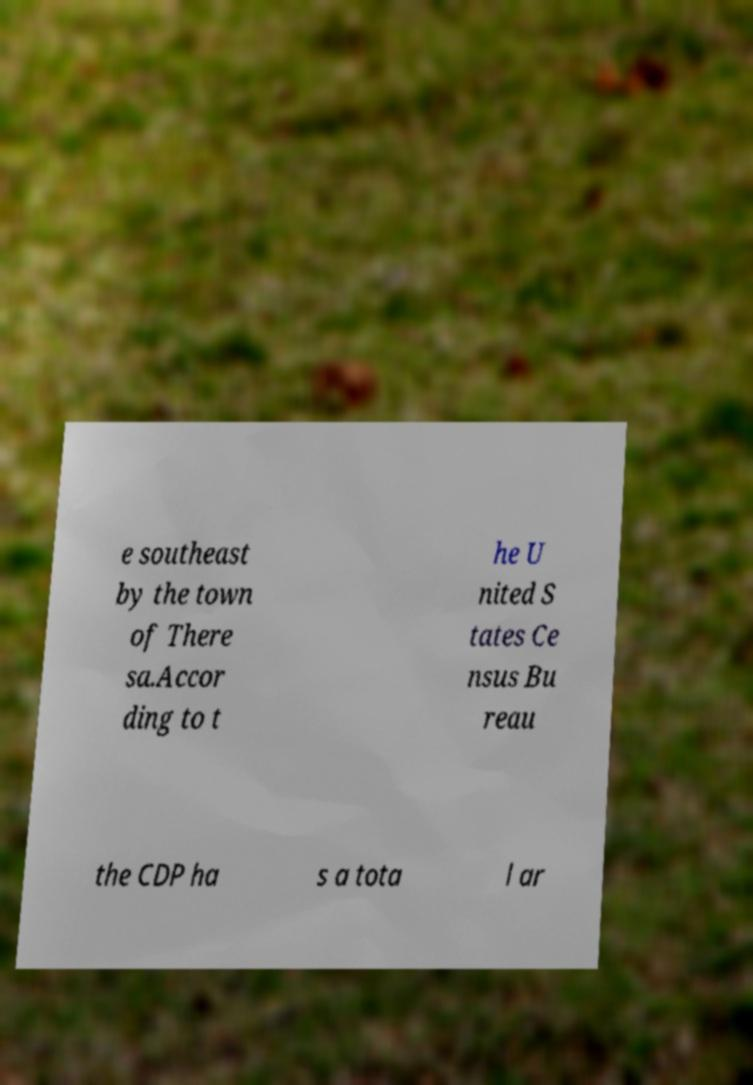I need the written content from this picture converted into text. Can you do that? e southeast by the town of There sa.Accor ding to t he U nited S tates Ce nsus Bu reau the CDP ha s a tota l ar 